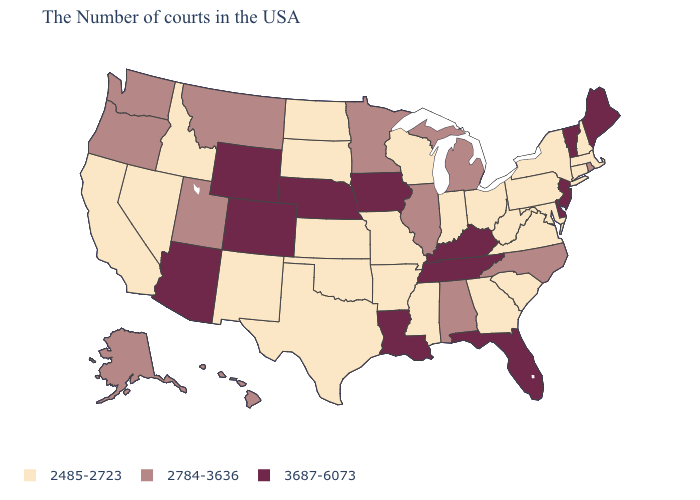What is the value of Louisiana?
Be succinct. 3687-6073. Which states have the lowest value in the South?
Quick response, please. Maryland, Virginia, South Carolina, West Virginia, Georgia, Mississippi, Arkansas, Oklahoma, Texas. What is the lowest value in states that border Idaho?
Answer briefly. 2485-2723. What is the value of Vermont?
Short answer required. 3687-6073. Among the states that border New Jersey , which have the lowest value?
Write a very short answer. New York, Pennsylvania. What is the value of Vermont?
Quick response, please. 3687-6073. Does Ohio have a higher value than Minnesota?
Quick response, please. No. Name the states that have a value in the range 3687-6073?
Keep it brief. Maine, Vermont, New Jersey, Delaware, Florida, Kentucky, Tennessee, Louisiana, Iowa, Nebraska, Wyoming, Colorado, Arizona. What is the highest value in the Northeast ?
Short answer required. 3687-6073. Which states have the lowest value in the South?
Write a very short answer. Maryland, Virginia, South Carolina, West Virginia, Georgia, Mississippi, Arkansas, Oklahoma, Texas. Which states have the lowest value in the USA?
Be succinct. Massachusetts, New Hampshire, Connecticut, New York, Maryland, Pennsylvania, Virginia, South Carolina, West Virginia, Ohio, Georgia, Indiana, Wisconsin, Mississippi, Missouri, Arkansas, Kansas, Oklahoma, Texas, South Dakota, North Dakota, New Mexico, Idaho, Nevada, California. What is the value of Massachusetts?
Write a very short answer. 2485-2723. Does Vermont have the lowest value in the USA?
Short answer required. No. What is the highest value in the West ?
Concise answer only. 3687-6073. What is the value of North Dakota?
Quick response, please. 2485-2723. 